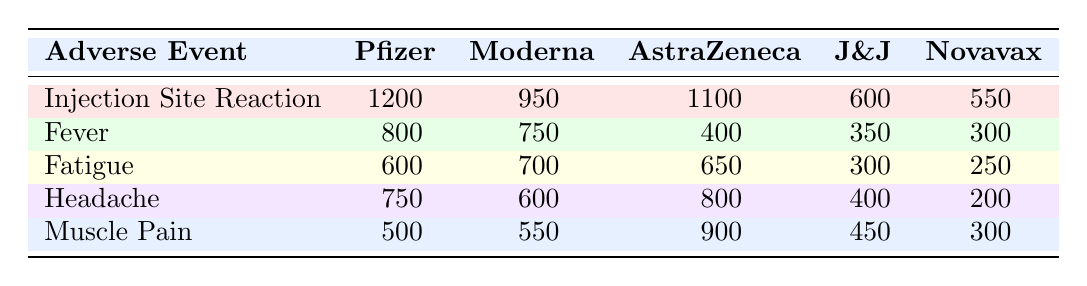What is the highest number of Injection Site Reactions reported among the vaccine candidates? The table shows that the Pfizer-BioNTech BNT162b2 has reported 1200 Injection Site Reactions, which is the highest number compared to the other candidates.
Answer: 1200 Which vaccine candidate reported the least number of Fever cases? The table indicates that Novavax NVX-CoV2373 reported 300 cases of Fever, which is the least among all candidates.
Answer: 300 What is the total number of Muscle Pain cases reported across all vaccine candidates? To find the total, add all the reported cases: 500 (Pfizer) + 550 (Moderna) + 900 (AstraZeneca) + 450 (J&J) + 300 (Novavax) = 2700.
Answer: 2700 Is there a vaccine candidate that reported more than 800 cases of Headache? The table shows that the AstraZeneca candidate reported 800 Headache cases, which qualifies as more than 800. Thus, the answer is yes.
Answer: Yes What is the average number of Fatigue cases reported by the vaccine candidates? The total number of Fatigue cases is 600 (Pfizer) + 700 (Moderna) + 650 (AstraZeneca) + 300 (J&J) + 250 (Novavax) = 2500. There are 5 candidates, so the average is 2500/5 = 500.
Answer: 500 Which vaccine candidate had fewer cases of Fever than Johnson & Johnson? Johnson & Johnson reported 350 cases of Fever, while Novavax reported 300 cases. Thus, Novavax NVX-CoV2373 had fewer cases than Johnson & Johnson.
Answer: Novavax NVX-CoV2373 What is the difference in the number of Injection Site Reactions between Pfizer-BioNTech and Johnson & Johnson? Pfizer-BioNTech reported 1200 Injection Site Reactions and Johnson & Johnson reported 600. The difference is 1200 - 600 = 600.
Answer: 600 Did any vaccine candidate report more cases of Muscle Pain than the reported average of all candidates? The average Muscle Pain cases can be calculated as (500 + 550 + 900 + 450 + 300) / 5 = 570. AstraZeneca reported 900 Muscle Pain cases, which is more than the average. Thus, yes.
Answer: Yes 